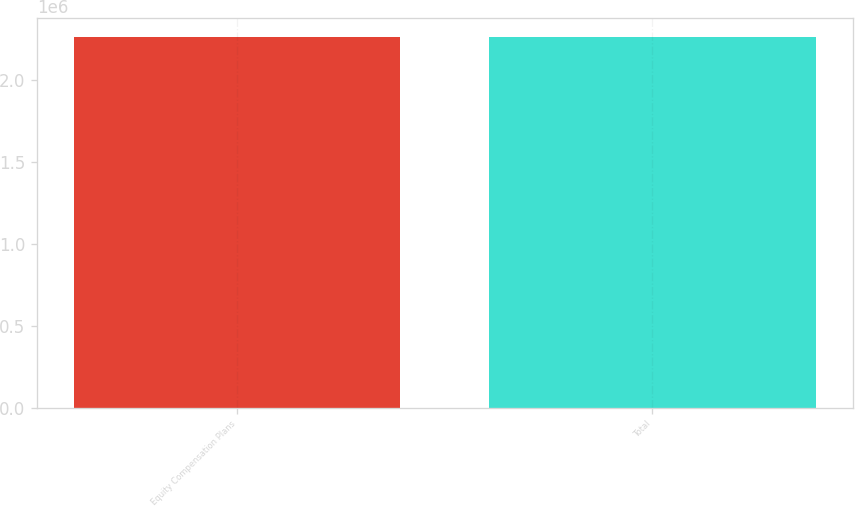<chart> <loc_0><loc_0><loc_500><loc_500><bar_chart><fcel>Equity Compensation Plans<fcel>Total<nl><fcel>2.26245e+06<fcel>2.26245e+06<nl></chart> 